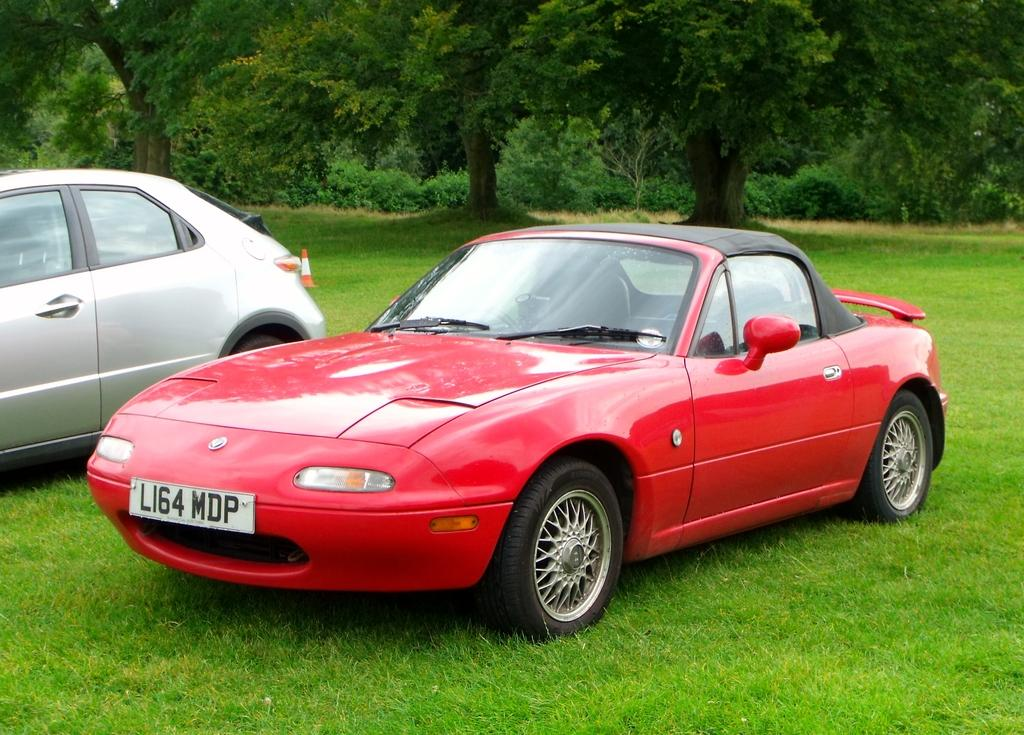How many cars are present in the image? There are two cars in the image. What is placed on the grass in the image? There is a traffic cone on the grass. What type of vegetation can be seen at the top of the image? Trees are visible at the top of the image. What type of trousers are the dolls wearing in the image? There are no dolls or trousers present in the image. 